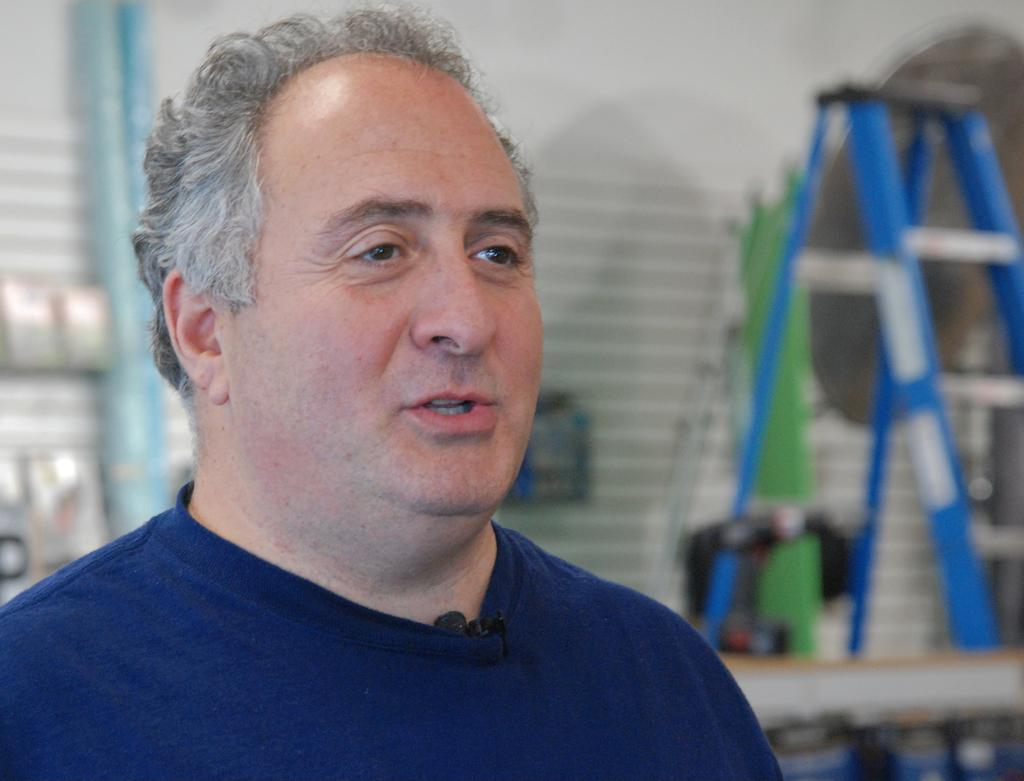What is the main subject of the image? There is a person sitting in the image. Can you describe the background of the image? The background of the image is blurred. What type of tools is the carpenter using to work on the oranges in the image? There is no carpenter or oranges present in the image, and therefore no such activity can be observed. 